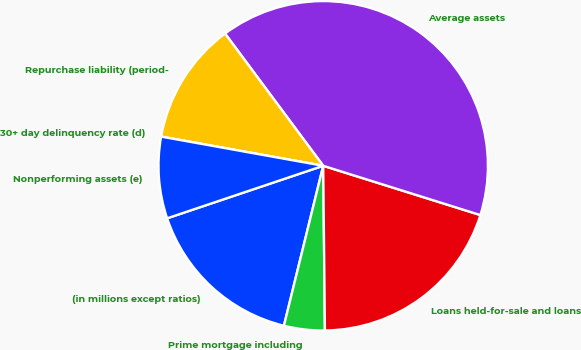Convert chart. <chart><loc_0><loc_0><loc_500><loc_500><pie_chart><fcel>(in millions except ratios)<fcel>Prime mortgage including<fcel>Loans held-for-sale and loans<fcel>Average assets<fcel>Repurchase liability (period-<fcel>30+ day delinquency rate (d)<fcel>Nonperforming assets (e)<nl><fcel>16.0%<fcel>4.0%<fcel>20.0%<fcel>40.0%<fcel>12.0%<fcel>0.0%<fcel>8.0%<nl></chart> 